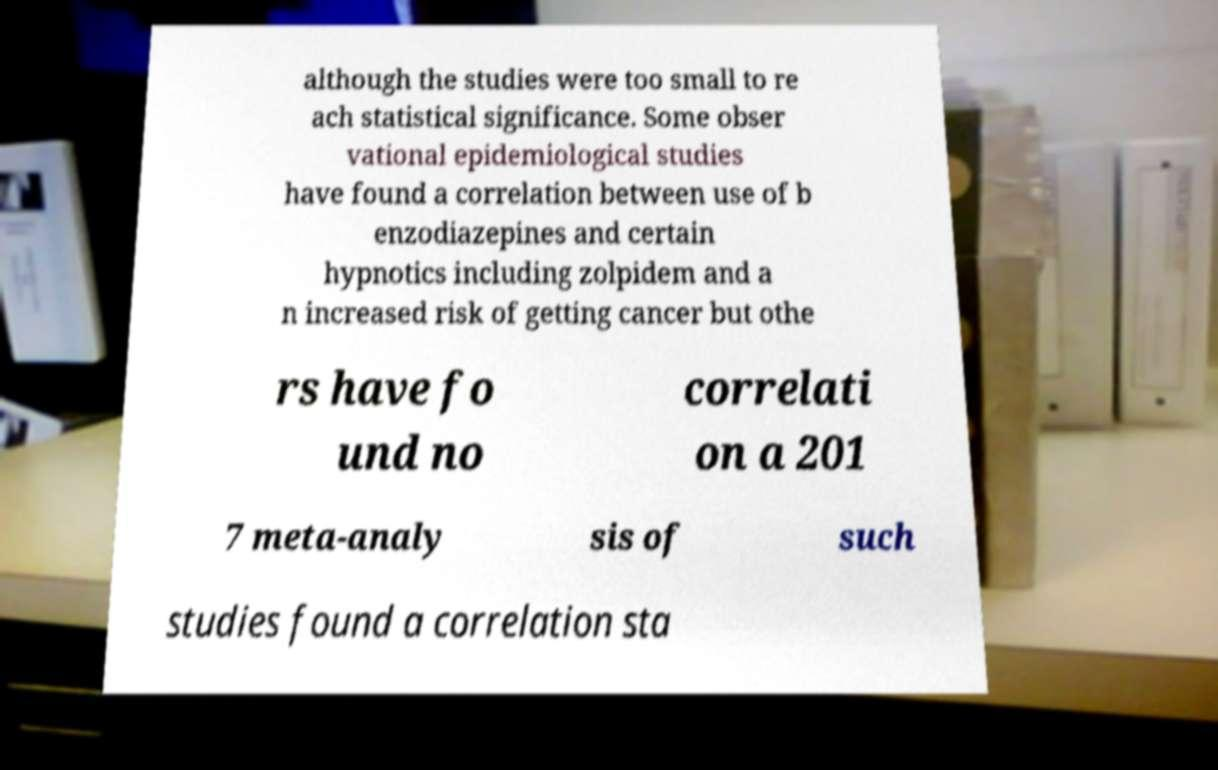Can you read and provide the text displayed in the image?This photo seems to have some interesting text. Can you extract and type it out for me? although the studies were too small to re ach statistical significance. Some obser vational epidemiological studies have found a correlation between use of b enzodiazepines and certain hypnotics including zolpidem and a n increased risk of getting cancer but othe rs have fo und no correlati on a 201 7 meta-analy sis of such studies found a correlation sta 